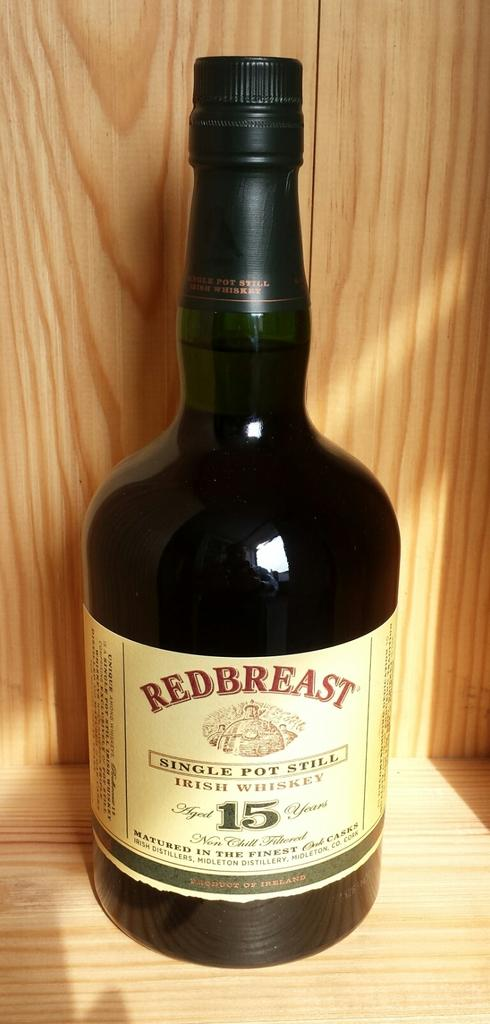Provide a one-sentence caption for the provided image. A bottle of Redbreast Irish whiskey on a wooden shelf. 